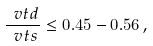<formula> <loc_0><loc_0><loc_500><loc_500>\frac { \ v t d } { \ v t s } \leq 0 . 4 5 - 0 . 5 6 \, ,</formula> 